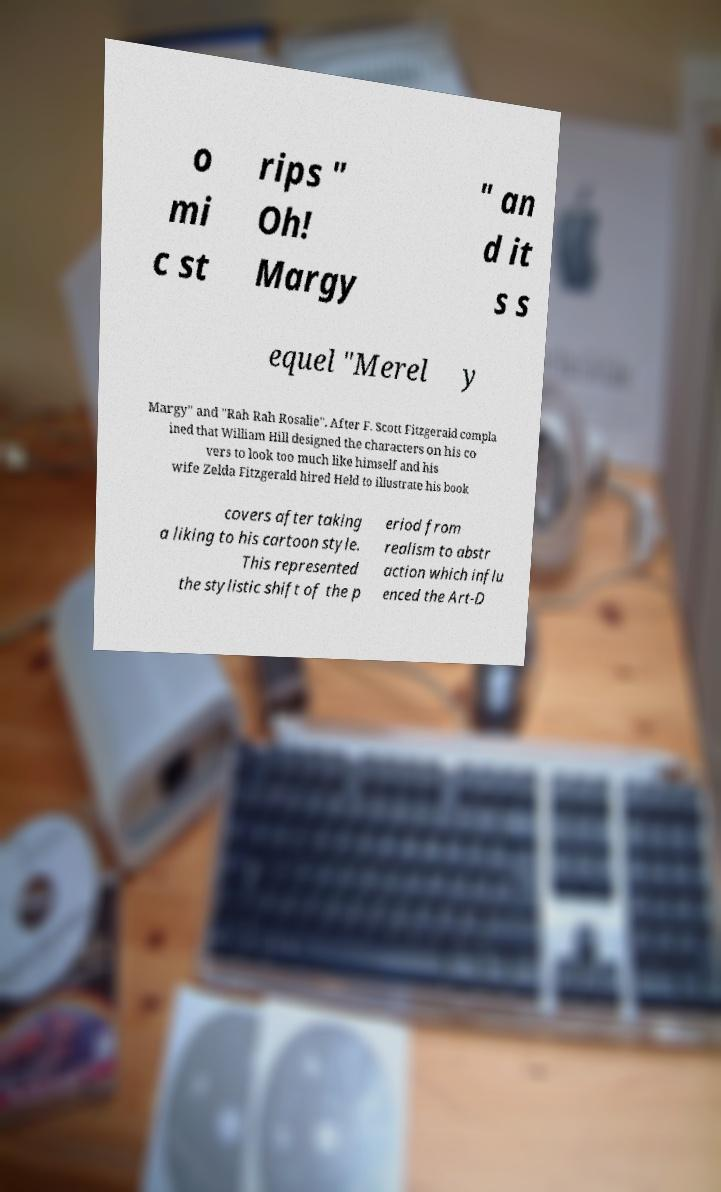For documentation purposes, I need the text within this image transcribed. Could you provide that? o mi c st rips " Oh! Margy " an d it s s equel "Merel y Margy" and "Rah Rah Rosalie". After F. Scott Fitzgerald compla ined that William Hill designed the characters on his co vers to look too much like himself and his wife Zelda Fitzgerald hired Held to illustrate his book covers after taking a liking to his cartoon style. This represented the stylistic shift of the p eriod from realism to abstr action which influ enced the Art-D 